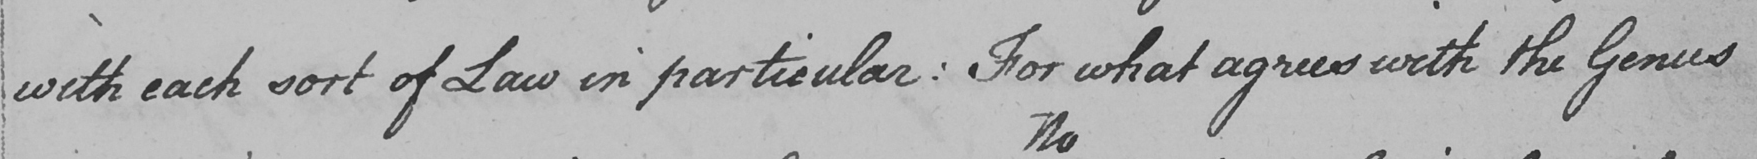Please transcribe the handwritten text in this image. with each sort of Law in particular :  For what agrees with the Genus 